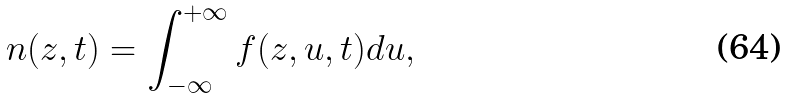Convert formula to latex. <formula><loc_0><loc_0><loc_500><loc_500>n ( z , t ) = \int _ { - \infty } ^ { + \infty } f ( z , u , t ) d u ,</formula> 